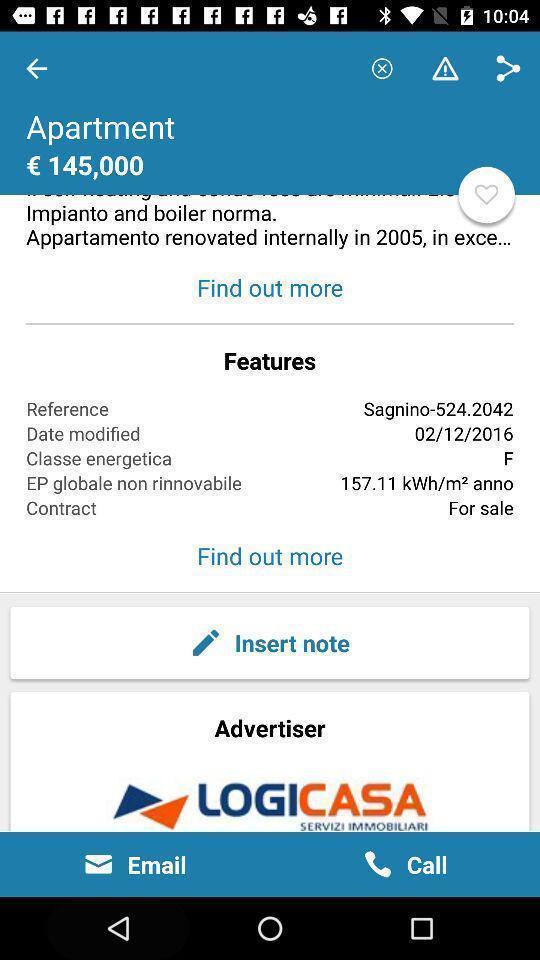Provide a description of this screenshot. Screen page displaying various options. 